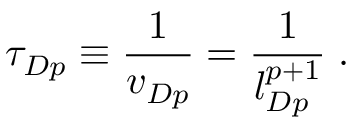<formula> <loc_0><loc_0><loc_500><loc_500>\tau _ { D p } \equiv \frac { 1 } { v _ { D p } } = \frac { 1 } { l _ { D p } ^ { p + 1 } } \, .</formula> 